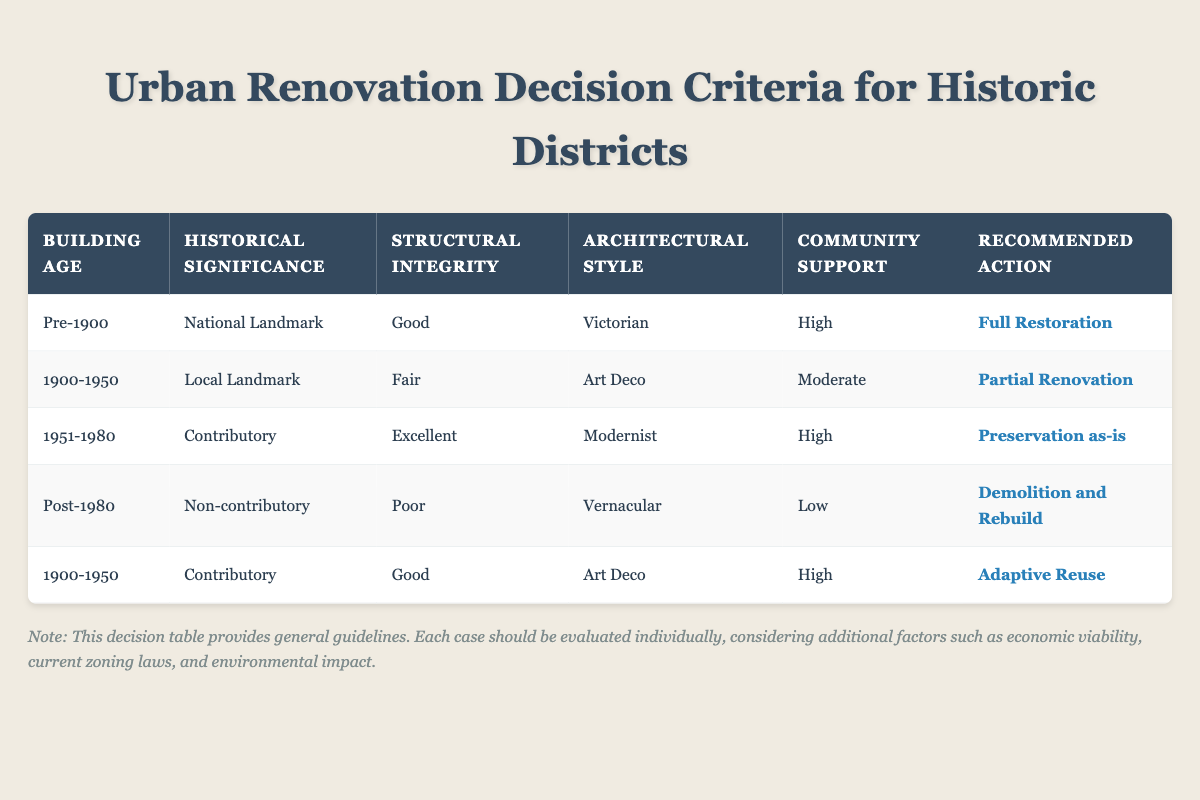What is the recommended action for a building that is a National Landmark built pre-1900 with good structural integrity and high community support? The table shows that for a building that is pre-1900, classified as a National Landmark, with good structural integrity, and high community support, the recommended action is "Full Restoration." This can be found directly in the first row of the table.
Answer: Full Restoration Which architectural style is associated with preservation as-is for buildings from 1951-1980 that are contributory and in excellent condition? According to the table, the recommended action "Preservation as-is" is associated with buildings built between 1951 and 1980 that are contributory and have excellent structural integrity. The architectural style associated with this action is "Modernist," which is specified in the third row.
Answer: Modernist Is there a recommended action for buildings constructed post-1980 that are in poor structural condition and have no historical significance? Yes, for buildings constructed post-1980 classified as non-contributory with poor structural integrity, the action recommended is "Demolition and Rebuild." This can be confirmed by looking at the fourth row in the table.
Answer: Yes How many different recommended actions apply to buildings between 1900 and 1950? In the table, there are two distinct recommended actions for buildings from 1900 to 1950. These actions are "Partial Renovation" for a Local Landmark with fair structural integrity and "Adaptive Reuse" for a Contributory building with good structural integrity. Thus, there are a total of two different actions for this time period.
Answer: 2 What is the average building age represented in the table? The ages represented in the table are Pre-1900, 1900-1950, 1951-1980, and Post-1980. To compute an average age, we could assign a numerical value such as 1800 for Pre-1900, 1925 for 1900-1950, 1965 for 1951-1980, and 2000 for Post-1980. Then, look at how many buildings fall in each range. Assessing these further would yield an average age of (1800 + 1925 + 1965 + 2000)/4 = 1922.5.
Answer: 1922.5 What is the recommended action for a Low community support rating for a non-contributory building post-1980? The table indicates that the recommended action for a non-contributory building post-1980, which also has low community support, is "Demolition and Rebuild." This is illustrated in the fourth row of the table.
Answer: Demolition and Rebuild 